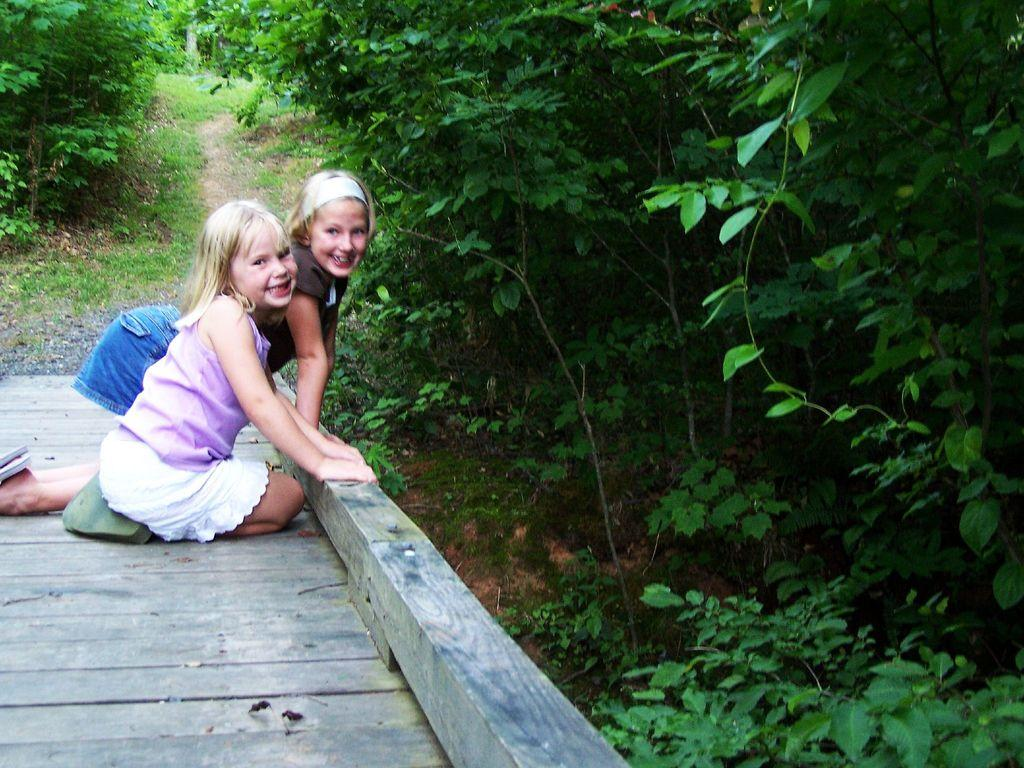How many girls are in the image? There are two girls in the foreground of the image. What surface are the girls on? The girls are on a wooden surface. What can be seen on the right side of the image? There are trees on the right side of the image. What is visible in the background of the image? There is a path, grass, and trees in the background of the image. What type of advertisement can be seen on the wooden surface in the image? There is no advertisement present on the wooden surface in the image. How many rabbits are visible in the image? There are no rabbits visible in the image. 